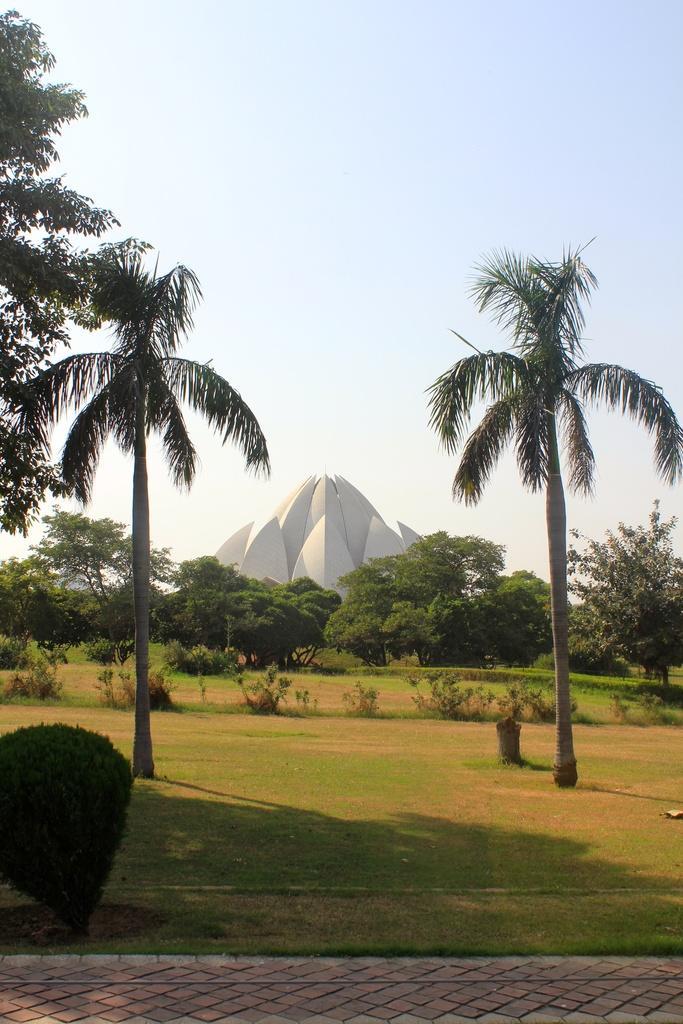Could you give a brief overview of what you see in this image? In this image we can see a monument. We can also see some trees around it, grass, shrubs and a pathway. On the backside we can see the sky which looks cloudy. 